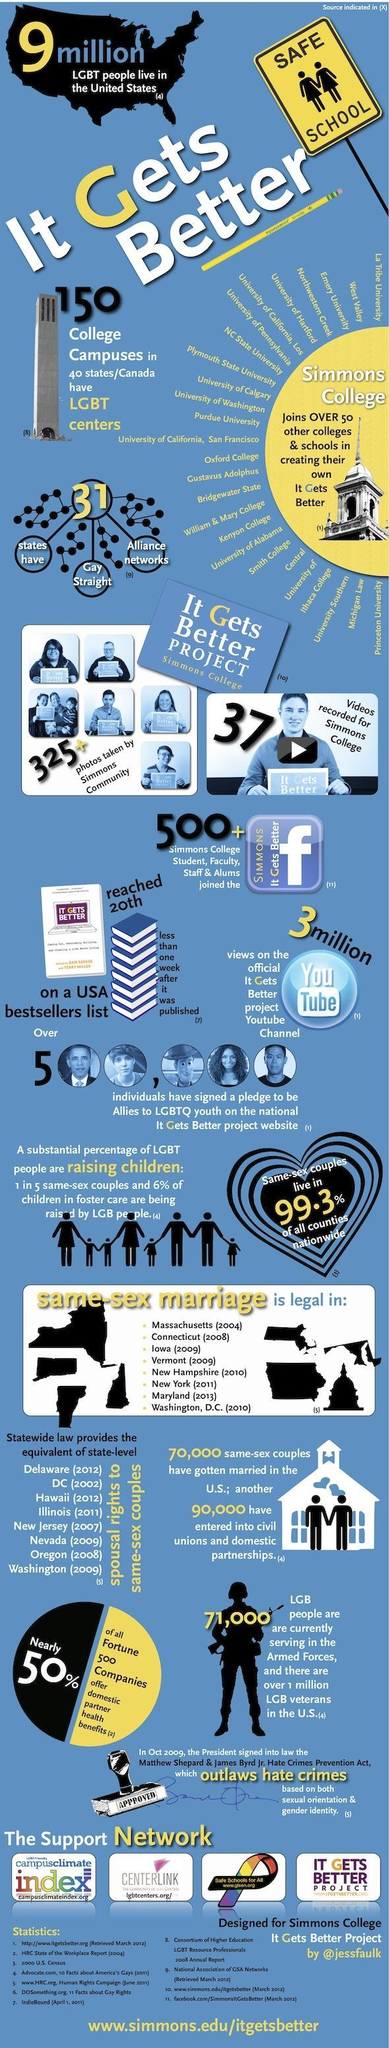How many youtube views did It Gets Better Project receive?
Answer the question with a short phrase. 3 million How many people signed pledge on the website? 500,000 From when is same sex marriage legal in Iowa? 2009 How many states provide spousal rights to same-sex couples? 8 How many states have alliance networks for gay straights? 31 How many LGB people are serving in the Armed forces? 71,000 In how many states is same-sex marriage legal? 8 